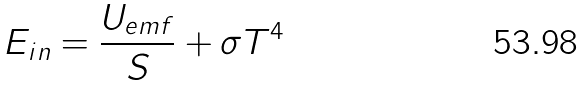Convert formula to latex. <formula><loc_0><loc_0><loc_500><loc_500>E _ { i n } = \frac { U _ { e m f } } { S } + \sigma T ^ { 4 }</formula> 